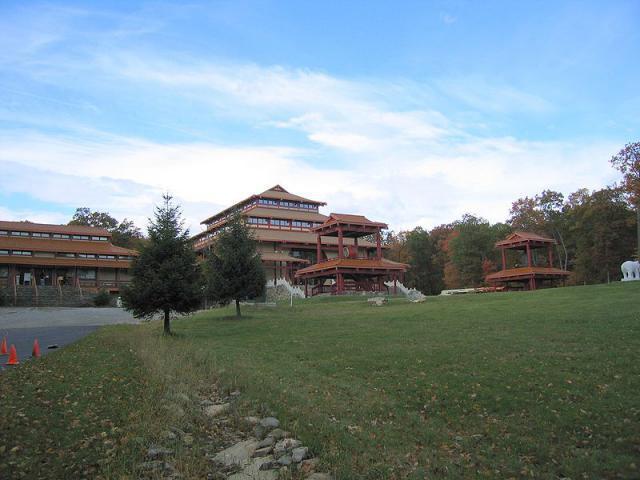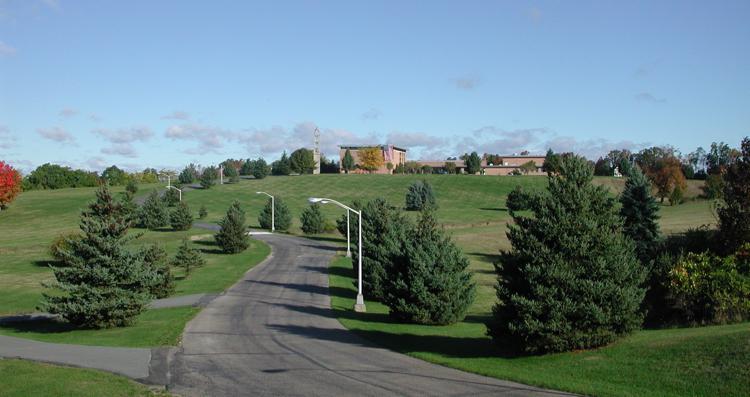The first image is the image on the left, the second image is the image on the right. Considering the images on both sides, is "At least one image shows a person with a shaved head wearing a solid-colored robe." valid? Answer yes or no. No. The first image is the image on the left, the second image is the image on the right. Evaluate the accuracy of this statement regarding the images: "At least one person is posing while wearing a robe.". Is it true? Answer yes or no. No. 